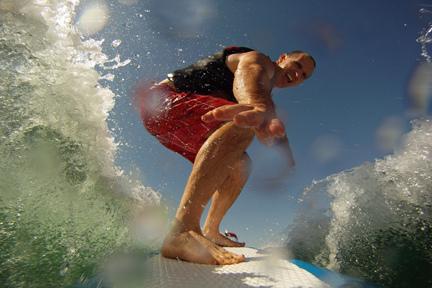What color are the waves?
Be succinct. Green. Is the man happy?
Keep it brief. Yes. What type of body of water is this?
Give a very brief answer. Ocean. What is the man doing?
Answer briefly. Surfing. Is the man wearing earplugs?
Write a very short answer. No. 